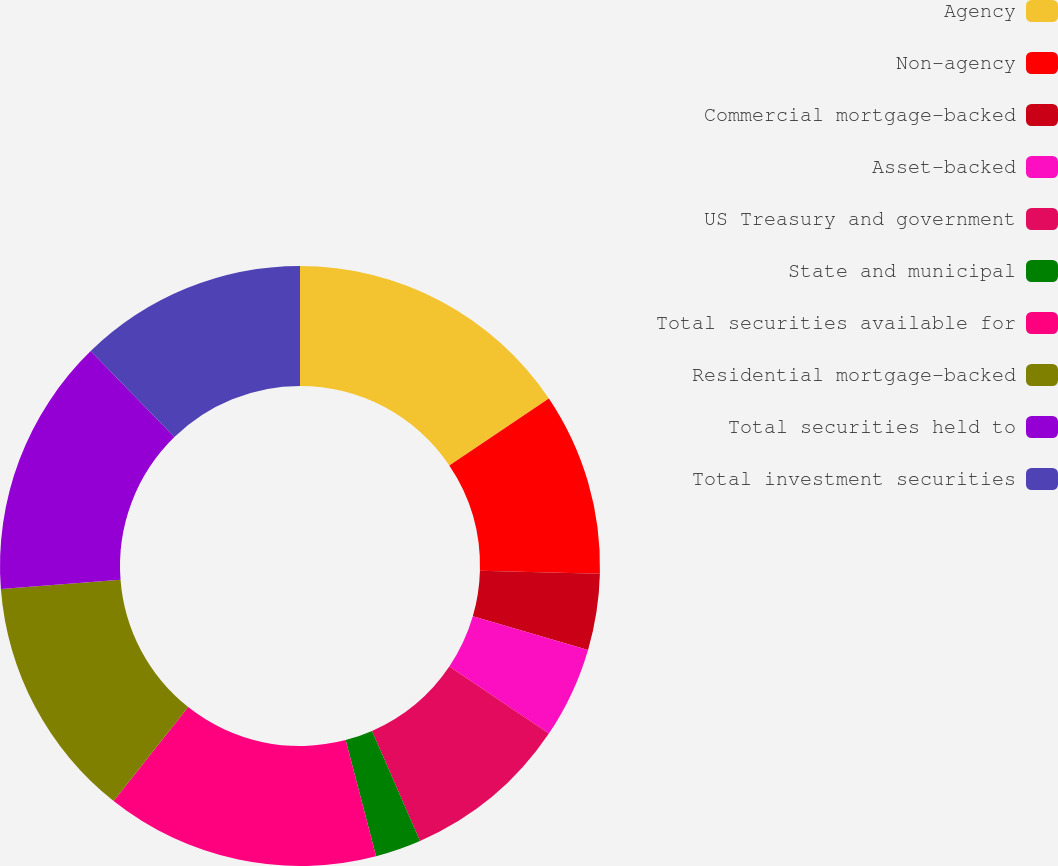<chart> <loc_0><loc_0><loc_500><loc_500><pie_chart><fcel>Agency<fcel>Non-agency<fcel>Commercial mortgage-backed<fcel>Asset-backed<fcel>US Treasury and government<fcel>State and municipal<fcel>Total securities available for<fcel>Residential mortgage-backed<fcel>Total securities held to<fcel>Total investment securities<nl><fcel>15.57%<fcel>9.84%<fcel>4.1%<fcel>4.92%<fcel>9.02%<fcel>2.47%<fcel>14.75%<fcel>13.11%<fcel>13.93%<fcel>12.29%<nl></chart> 